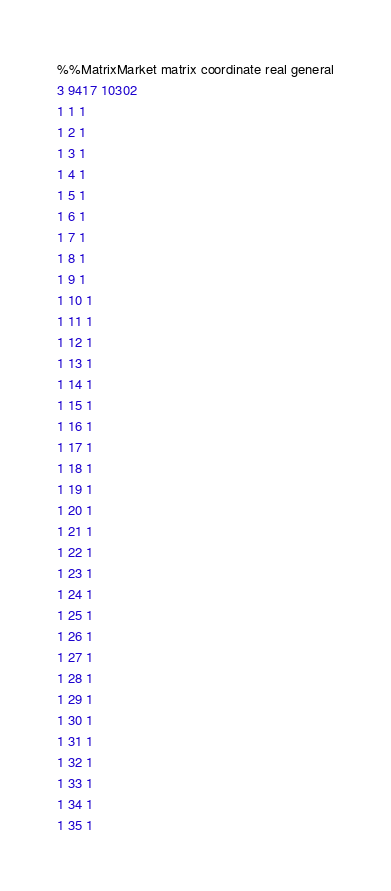Convert code to text. <code><loc_0><loc_0><loc_500><loc_500><_ObjectiveC_>%%MatrixMarket matrix coordinate real general
3 9417 10302                                      
1 1 1
1 2 1
1 3 1
1 4 1
1 5 1
1 6 1
1 7 1
1 8 1
1 9 1
1 10 1
1 11 1
1 12 1
1 13 1
1 14 1
1 15 1
1 16 1
1 17 1
1 18 1
1 19 1
1 20 1
1 21 1
1 22 1
1 23 1
1 24 1
1 25 1
1 26 1
1 27 1
1 28 1
1 29 1
1 30 1
1 31 1
1 32 1
1 33 1
1 34 1
1 35 1</code> 